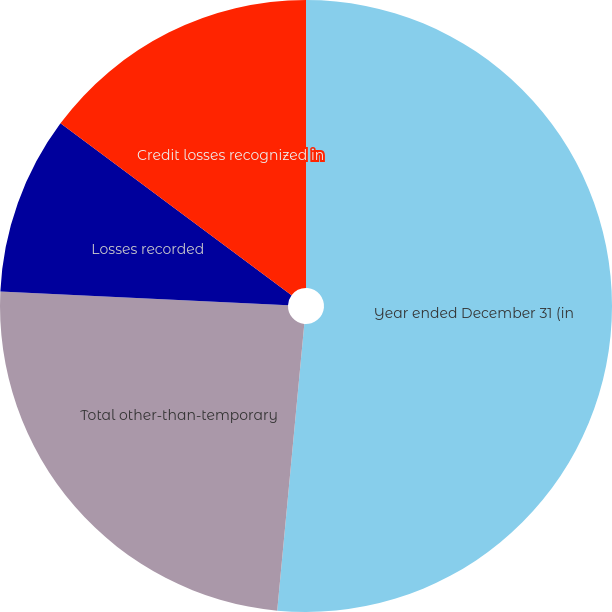<chart> <loc_0><loc_0><loc_500><loc_500><pie_chart><fcel>Year ended December 31 (in<fcel>Total other-than-temporary<fcel>Losses recorded<fcel>Credit losses recognized in<nl><fcel>51.5%<fcel>24.25%<fcel>9.43%<fcel>14.82%<nl></chart> 